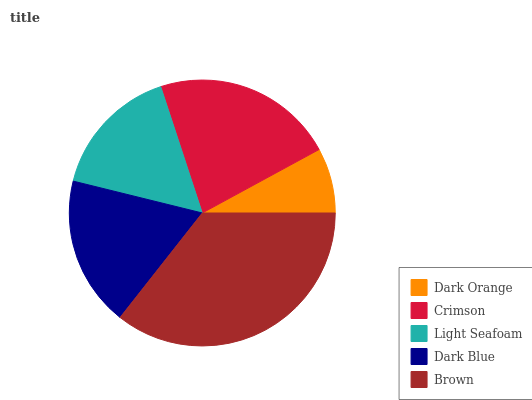Is Dark Orange the minimum?
Answer yes or no. Yes. Is Brown the maximum?
Answer yes or no. Yes. Is Crimson the minimum?
Answer yes or no. No. Is Crimson the maximum?
Answer yes or no. No. Is Crimson greater than Dark Orange?
Answer yes or no. Yes. Is Dark Orange less than Crimson?
Answer yes or no. Yes. Is Dark Orange greater than Crimson?
Answer yes or no. No. Is Crimson less than Dark Orange?
Answer yes or no. No. Is Dark Blue the high median?
Answer yes or no. Yes. Is Dark Blue the low median?
Answer yes or no. Yes. Is Brown the high median?
Answer yes or no. No. Is Light Seafoam the low median?
Answer yes or no. No. 